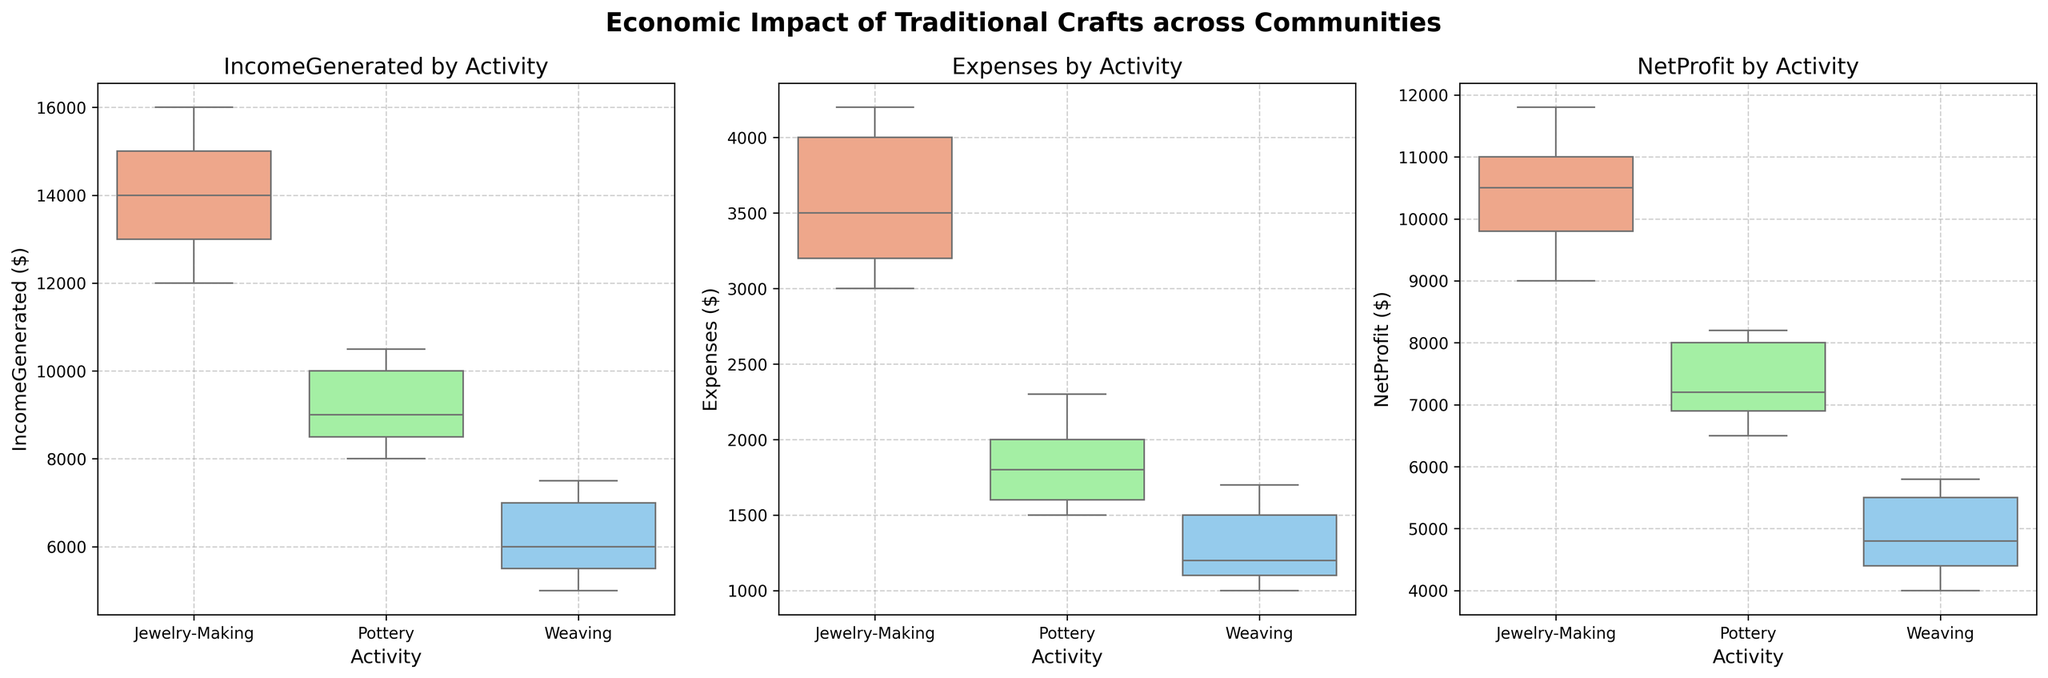What's the title of the figure? The title of the figure is directly displayed on top.
Answer: Economic Impact of Traditional Crafts across Communities What are the three metrics being compared in the subplots? The metrics are displayed as titles for each subplot: 'Income Generated', 'Expenses', and 'Net Profit'.
Answer: IncomeGenerated, Expenses, NetProfit How many distinct activities are compared in each subplot? Looking at the x-axis of each subplot, there are three distinct activities: Jewelry-Making, Pottery, and Weaving.
Answer: 3 Which activity has the highest median IncomeGenerated? By examining the median (the central line in each box), Jewelry-Making has the highest central line among the activities for the 'Income Generated' subplot.
Answer: Jewelry-Making Which craft has the lowest median NetProfit? We look at the 'Net Profit' subplot and compare the central lines in each box. The lowest central line is for Weaving.
Answer: Weaving Are the Expenses for Jewelry-Making generally higher than Pottery and Weaving? By comparing the median lines in the 'Expenses' subplot, we see that Jewelry-Making has higher median expenses compared to the other activities.
Answer: Yes Which activity shows the most variability in IncomeGenerated? Variability can be assessed by the height of the box in the 'Income Generated' subplot. Jewelry-Making has the tallest box, indicating the most variability.
Answer: Jewelry-Making Is the median NetProfit for Pottery greater than Weaving? In the 'Net Profit' subplot, comparing the central lines for Pottery and Weaving shows that Pottery has a higher median line.
Answer: Yes Which activity has the smallest range of Expenses? The range is shown by the length of the whiskers in the 'Expenses' subplot. Pottery has the shortest whiskers, indicating the smallest range.
Answer: Pottery 